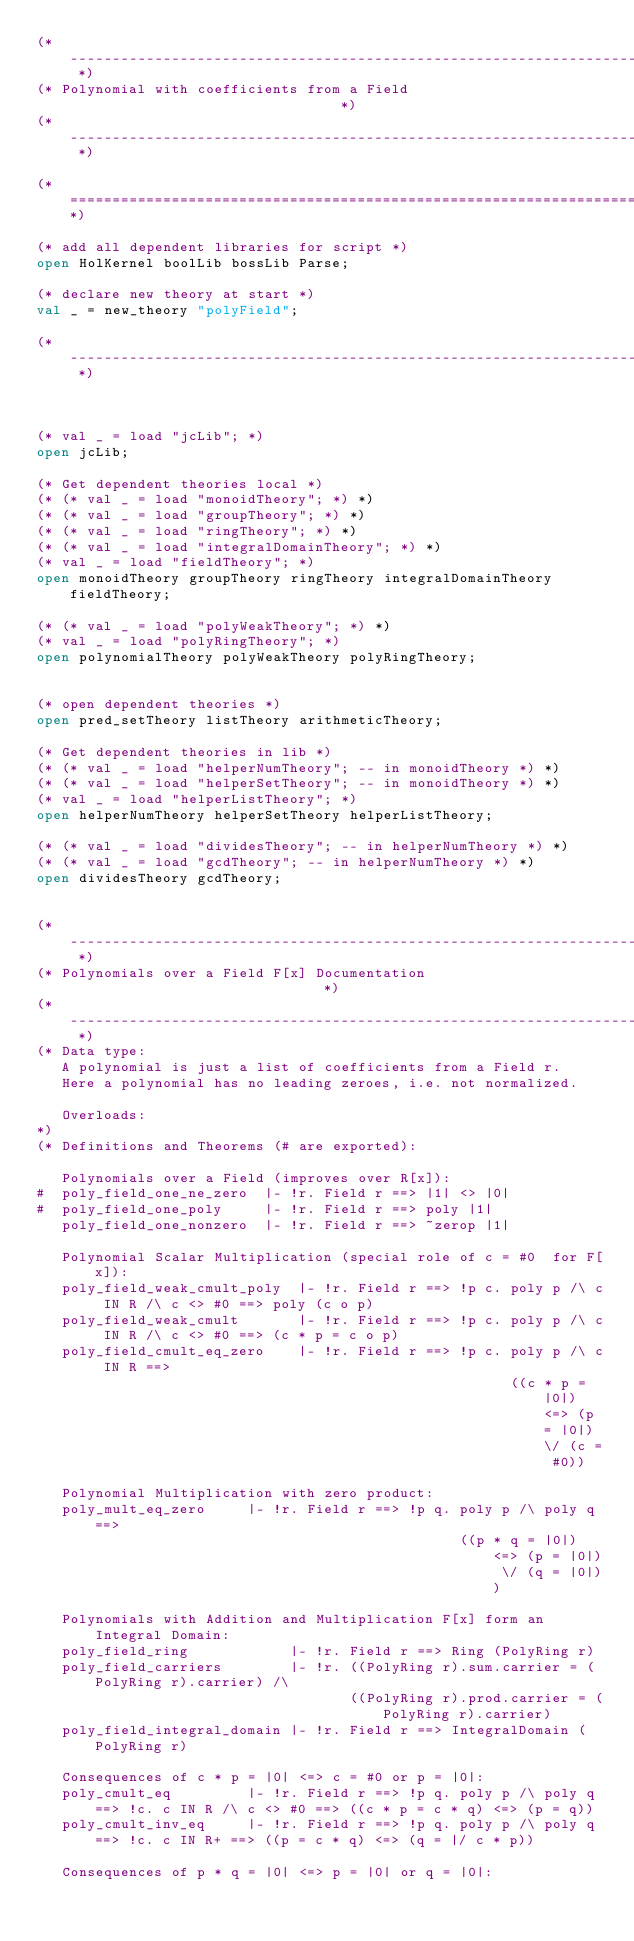Convert code to text. <code><loc_0><loc_0><loc_500><loc_500><_SML_>(* ------------------------------------------------------------------------- *)
(* Polynomial with coefficients from a Field                                 *)
(* ------------------------------------------------------------------------- *)

(*===========================================================================*)

(* add all dependent libraries for script *)
open HolKernel boolLib bossLib Parse;

(* declare new theory at start *)
val _ = new_theory "polyField";

(* ------------------------------------------------------------------------- *)



(* val _ = load "jcLib"; *)
open jcLib;

(* Get dependent theories local *)
(* (* val _ = load "monoidTheory"; *) *)
(* (* val _ = load "groupTheory"; *) *)
(* (* val _ = load "ringTheory"; *) *)
(* (* val _ = load "integralDomainTheory"; *) *)
(* val _ = load "fieldTheory"; *)
open monoidTheory groupTheory ringTheory integralDomainTheory fieldTheory;

(* (* val _ = load "polyWeakTheory"; *) *)
(* val _ = load "polyRingTheory"; *)
open polynomialTheory polyWeakTheory polyRingTheory;


(* open dependent theories *)
open pred_setTheory listTheory arithmeticTheory;

(* Get dependent theories in lib *)
(* (* val _ = load "helperNumTheory"; -- in monoidTheory *) *)
(* (* val _ = load "helperSetTheory"; -- in monoidTheory *) *)
(* val _ = load "helperListTheory"; *)
open helperNumTheory helperSetTheory helperListTheory;

(* (* val _ = load "dividesTheory"; -- in helperNumTheory *) *)
(* (* val _ = load "gcdTheory"; -- in helperNumTheory *) *)
open dividesTheory gcdTheory;


(* ------------------------------------------------------------------------- *)
(* Polynomials over a Field F[x] Documentation                               *)
(* ------------------------------------------------------------------------- *)
(* Data type:
   A polynomial is just a list of coefficients from a Field r.
   Here a polynomial has no leading zeroes, i.e. not normalized.

   Overloads:
*)
(* Definitions and Theorems (# are exported):

   Polynomials over a Field (improves over R[x]):
#  poly_field_one_ne_zero  |- !r. Field r ==> |1| <> |0|
#  poly_field_one_poly     |- !r. Field r ==> poly |1|
   poly_field_one_nonzero  |- !r. Field r ==> ~zerop |1|

   Polynomial Scalar Multiplication (special role of c = #0  for F[x]):
   poly_field_weak_cmult_poly  |- !r. Field r ==> !p c. poly p /\ c IN R /\ c <> #0 ==> poly (c o p)
   poly_field_weak_cmult       |- !r. Field r ==> !p c. poly p /\ c IN R /\ c <> #0 ==> (c * p = c o p)
   poly_field_cmult_eq_zero    |- !r. Field r ==> !p c. poly p /\ c IN R ==>
                                                        ((c * p = |0|) <=> (p = |0|) \/ (c = #0))

   Polynomial Multiplication with zero product:
   poly_mult_eq_zero     |- !r. Field r ==> !p q. poly p /\ poly q ==>
                                                  ((p * q = |0|) <=> (p = |0|) \/ (q = |0|))

   Polynomials with Addition and Multiplication F[x] form an Integral Domain:
   poly_field_ring            |- !r. Field r ==> Ring (PolyRing r)
   poly_field_carriers        |- !r. ((PolyRing r).sum.carrier = (PolyRing r).carrier) /\
                                     ((PolyRing r).prod.carrier = (PolyRing r).carrier)
   poly_field_integral_domain |- !r. Field r ==> IntegralDomain (PolyRing r)

   Consequences of c * p = |0| <=> c = #0 or p = |0|:
   poly_cmult_eq         |- !r. Field r ==> !p q. poly p /\ poly q ==> !c. c IN R /\ c <> #0 ==> ((c * p = c * q) <=> (p = q))
   poly_cmult_inv_eq     |- !r. Field r ==> !p q. poly p /\ poly q ==> !c. c IN R+ ==> ((p = c * q) <=> (q = |/ c * p))

   Consequences of p * q = |0| <=> p = |0| or q = |0|:</code> 